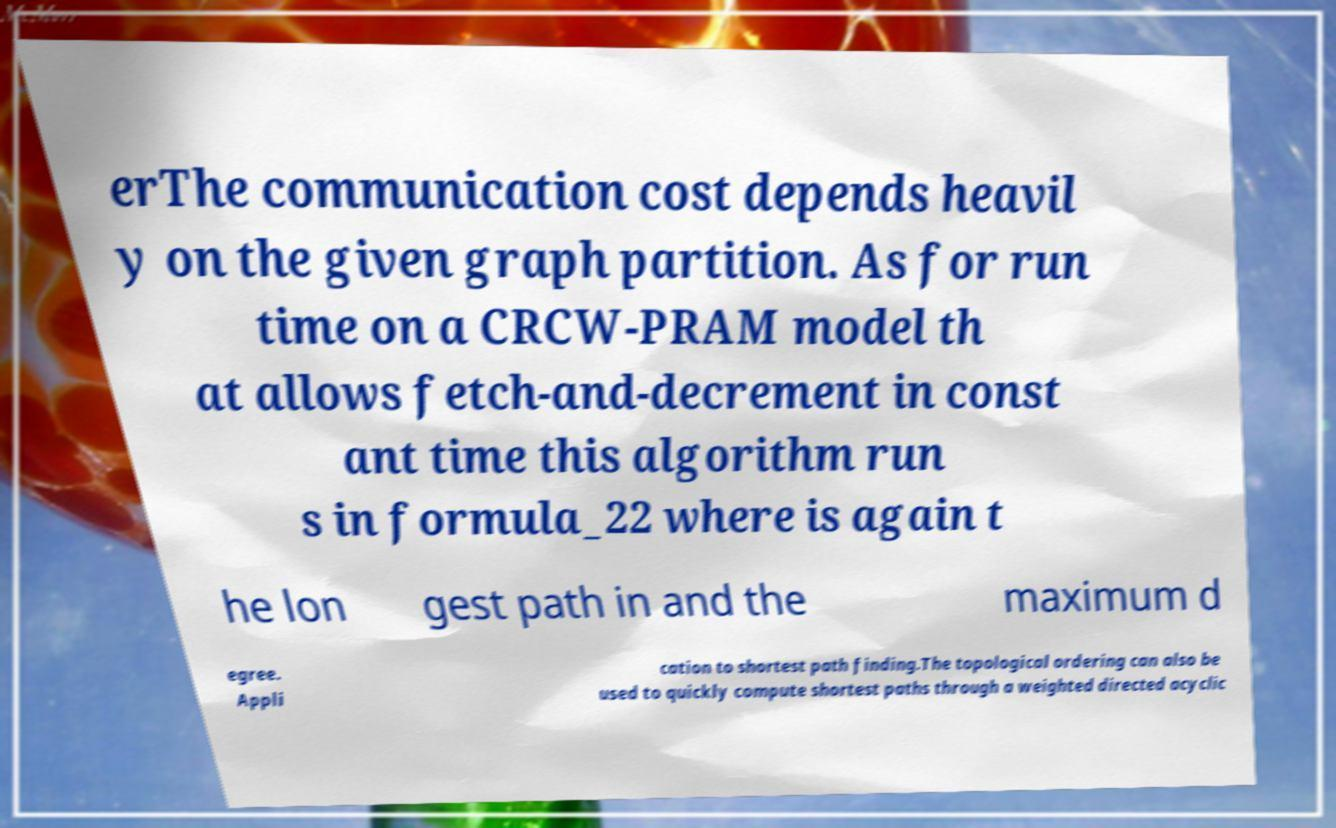Can you read and provide the text displayed in the image?This photo seems to have some interesting text. Can you extract and type it out for me? erThe communication cost depends heavil y on the given graph partition. As for run time on a CRCW-PRAM model th at allows fetch-and-decrement in const ant time this algorithm run s in formula_22 where is again t he lon gest path in and the maximum d egree. Appli cation to shortest path finding.The topological ordering can also be used to quickly compute shortest paths through a weighted directed acyclic 